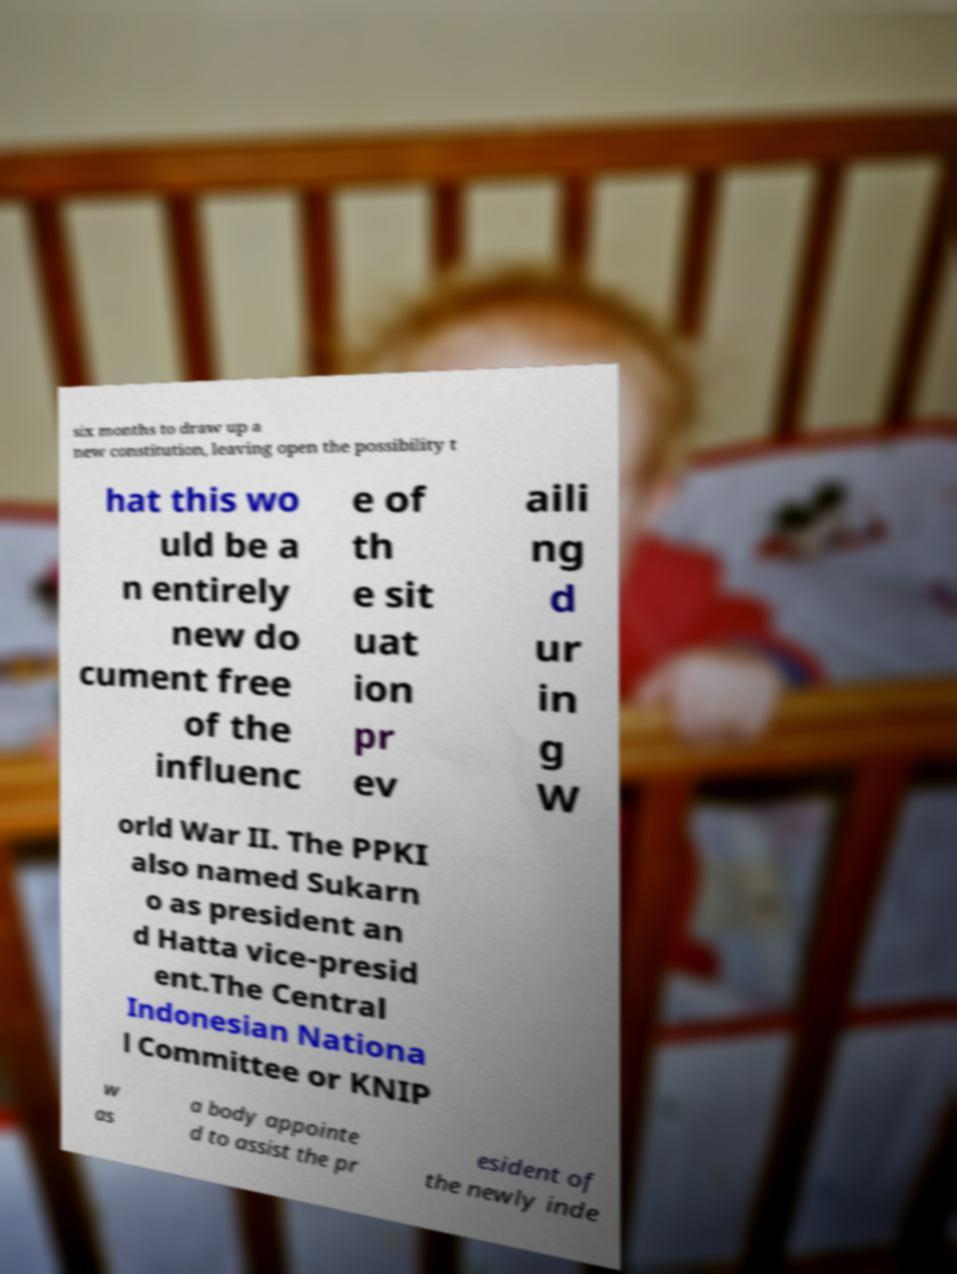Please read and relay the text visible in this image. What does it say? six months to draw up a new constitution, leaving open the possibility t hat this wo uld be a n entirely new do cument free of the influenc e of th e sit uat ion pr ev aili ng d ur in g W orld War II. The PPKI also named Sukarn o as president an d Hatta vice-presid ent.The Central Indonesian Nationa l Committee or KNIP w as a body appointe d to assist the pr esident of the newly inde 